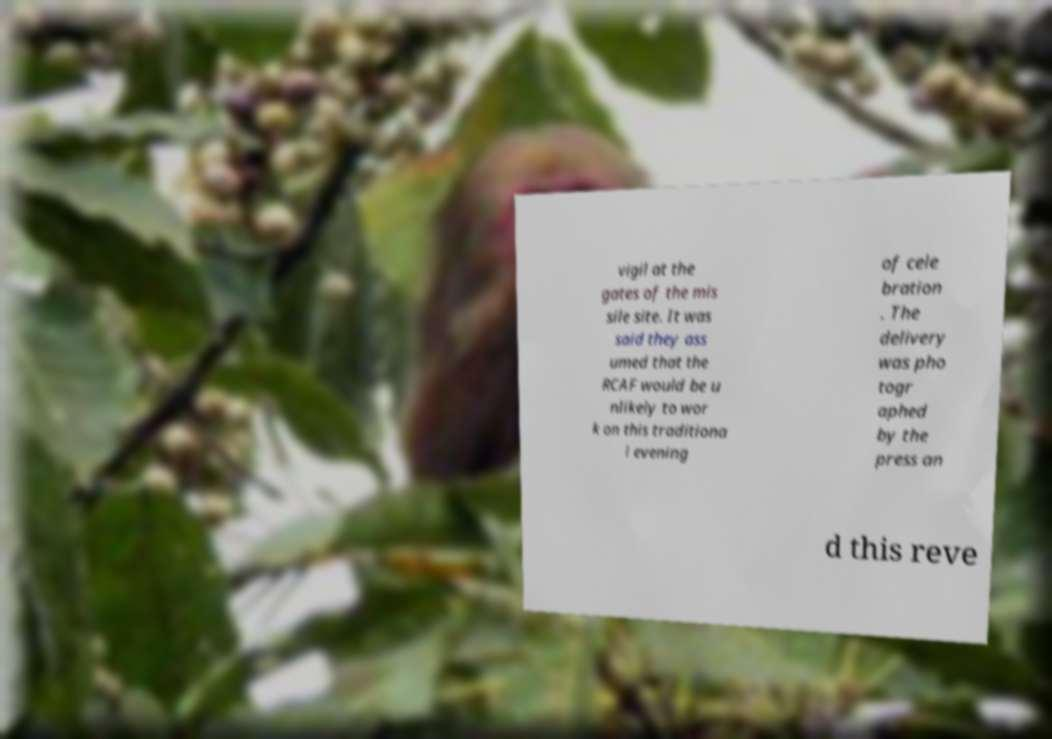Could you extract and type out the text from this image? vigil at the gates of the mis sile site. It was said they ass umed that the RCAF would be u nlikely to wor k on this traditiona l evening of cele bration . The delivery was pho togr aphed by the press an d this reve 